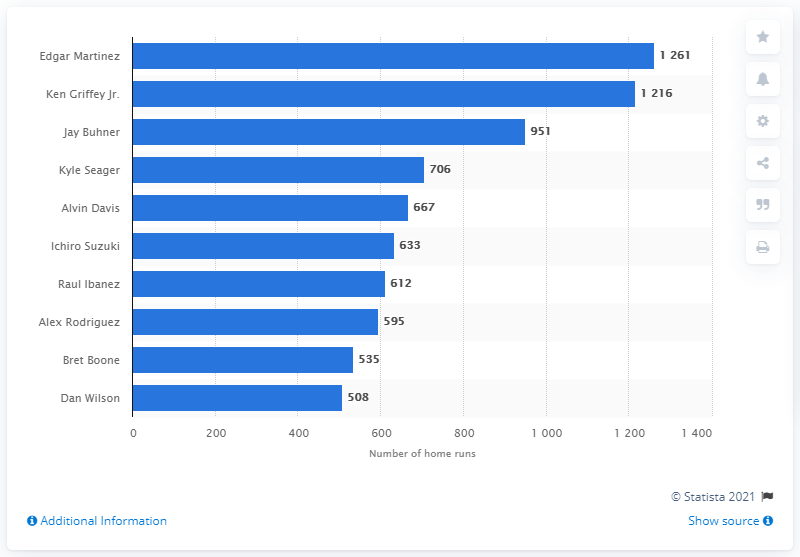Specify some key components in this picture. With a record-breaking 1,261 RBI, Edgar Martinez is the Seattle Mariners franchise's all-time leader in RBI, making him a dominant force in the sport. 